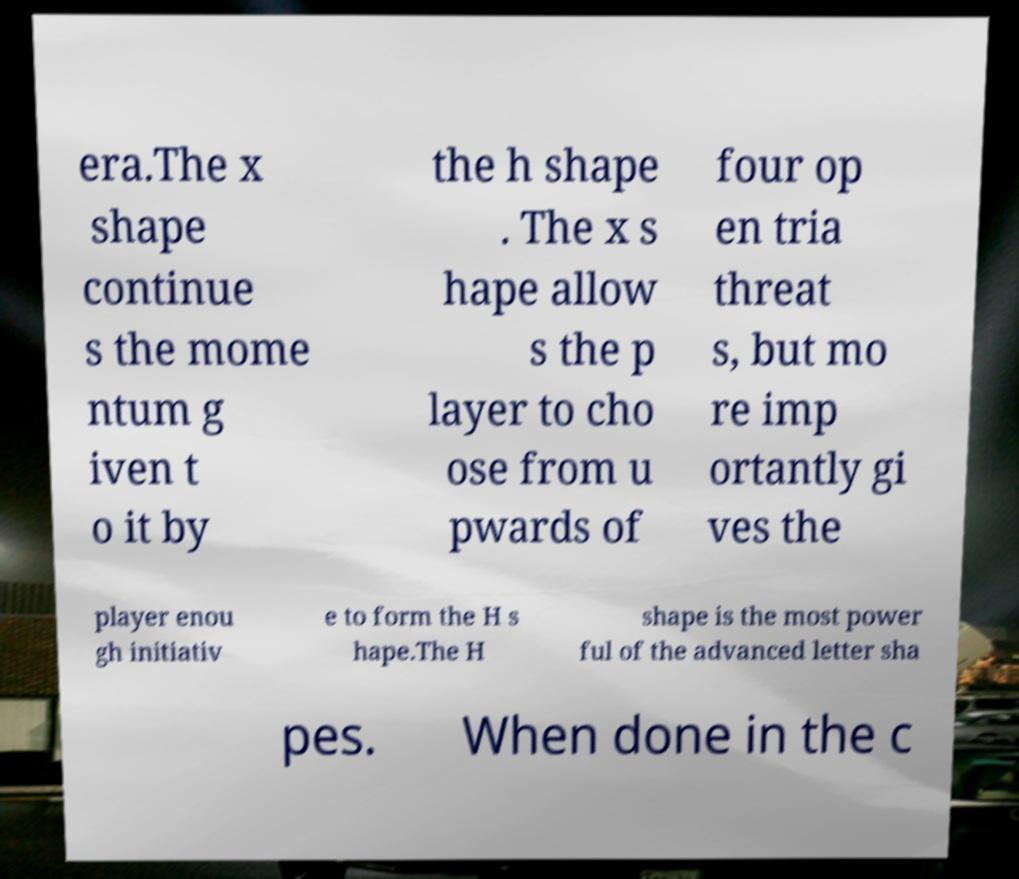Can you accurately transcribe the text from the provided image for me? era.The x shape continue s the mome ntum g iven t o it by the h shape . The x s hape allow s the p layer to cho ose from u pwards of four op en tria threat s, but mo re imp ortantly gi ves the player enou gh initiativ e to form the H s hape.The H shape is the most power ful of the advanced letter sha pes. When done in the c 